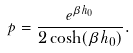<formula> <loc_0><loc_0><loc_500><loc_500>p = \frac { e ^ { \beta h _ { 0 } } } { 2 \cosh ( \beta h _ { 0 } ) } .</formula> 